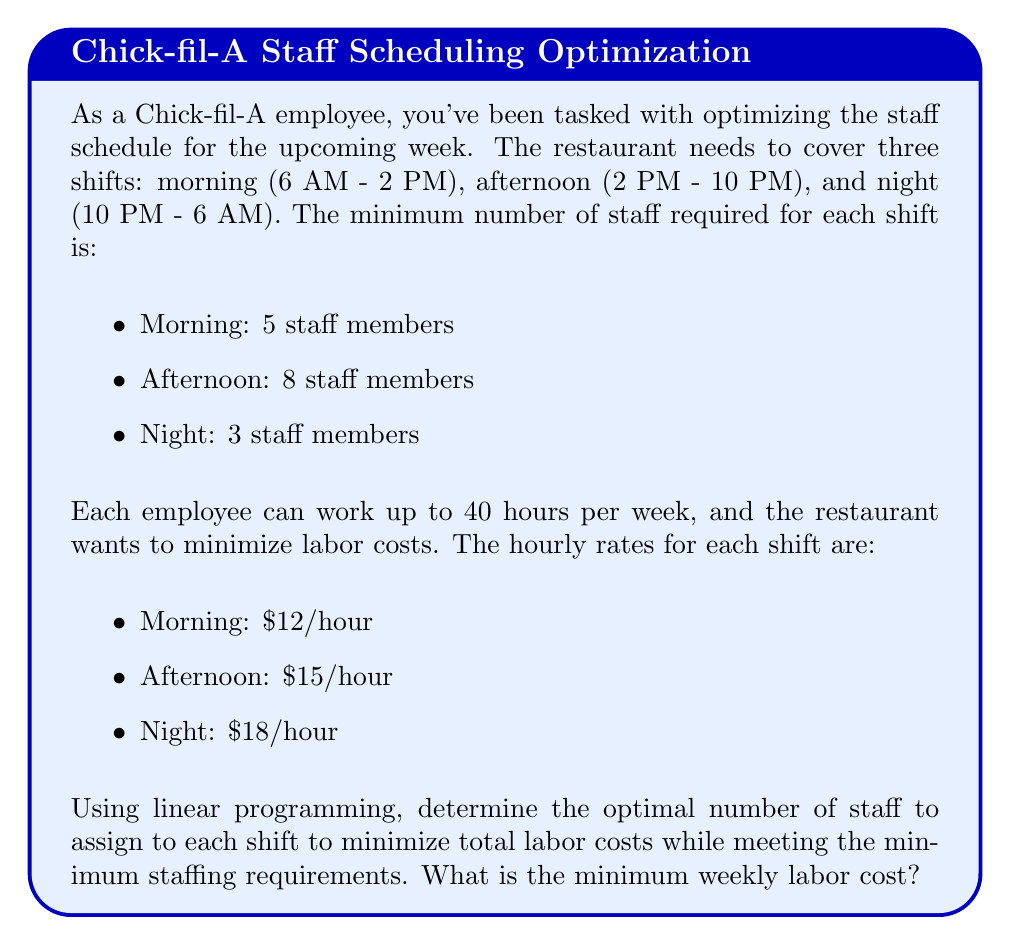What is the answer to this math problem? Let's solve this problem using linear programming:

1. Define variables:
   Let $x_1$, $x_2$, and $x_3$ be the number of staff assigned to morning, afternoon, and night shifts respectively.

2. Objective function:
   Minimize total labor cost:
   $$Z = 96x_1 + 120x_2 + 144x_3$$
   (8 hours per shift * hourly rate * number of staff)

3. Constraints:
   a) Minimum staffing requirements:
      $$x_1 \geq 5$$
      $$x_2 \geq 8$$
      $$x_3 \geq 3$$
   
   b) Total weekly hours constraint:
      $$56x_1 + 56x_2 + 56x_3 \leq 40(x_1 + x_2 + x_3)$$
      (56 hours per week per shift ≤ 40 hours * total staff)

4. Non-negativity:
   $$x_1, x_2, x_3 \geq 0$$

5. Simplify the total weekly hours constraint:
   $$16x_1 + 16x_2 + 16x_3 \leq 0$$
   $$x_1 + x_2 + x_3 \leq 0$$

6. Solve using the Simplex method or linear programming software:
   The optimal solution is:
   $$x_1 = 5, x_2 = 8, x_3 = 3$$

7. Calculate the minimum weekly labor cost:
   $$Z = 96(5) + 120(8) + 144(3) = 480 + 960 + 432 = 1872$$

Therefore, the minimum weekly labor cost is $1,872.
Answer: $1,872 